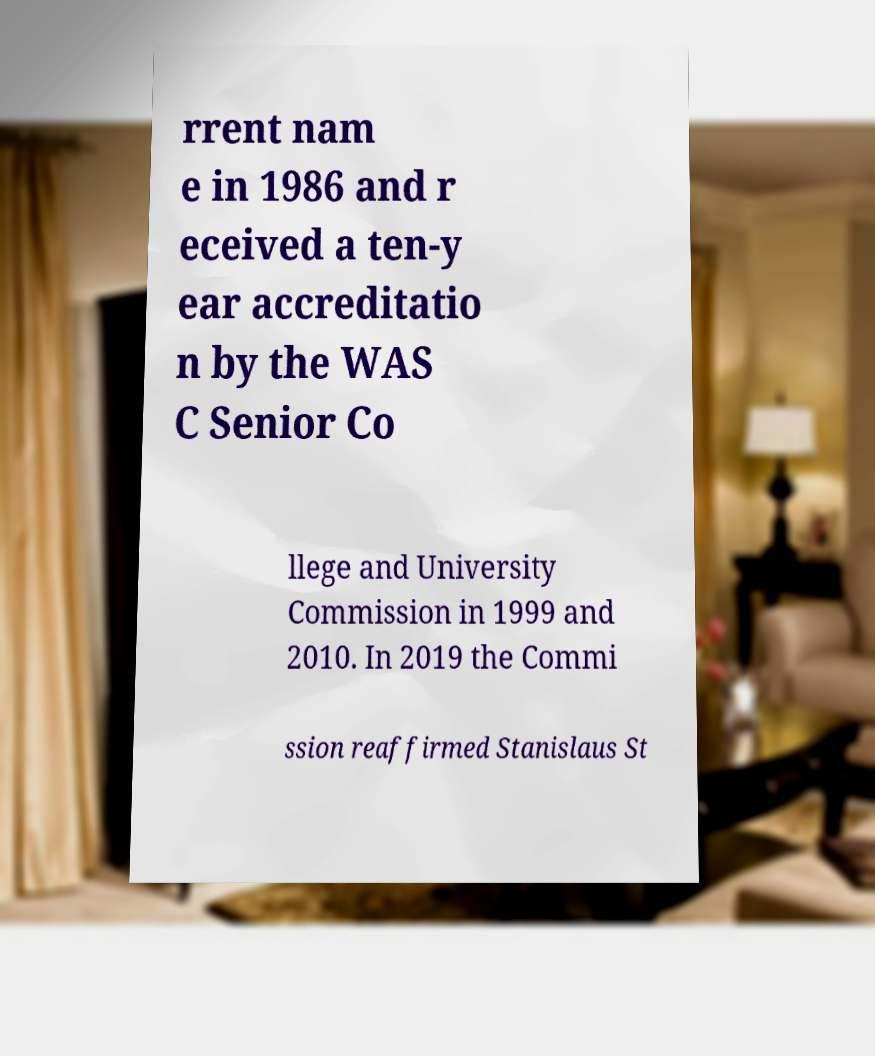Please identify and transcribe the text found in this image. rrent nam e in 1986 and r eceived a ten-y ear accreditatio n by the WAS C Senior Co llege and University Commission in 1999 and 2010. In 2019 the Commi ssion reaffirmed Stanislaus St 